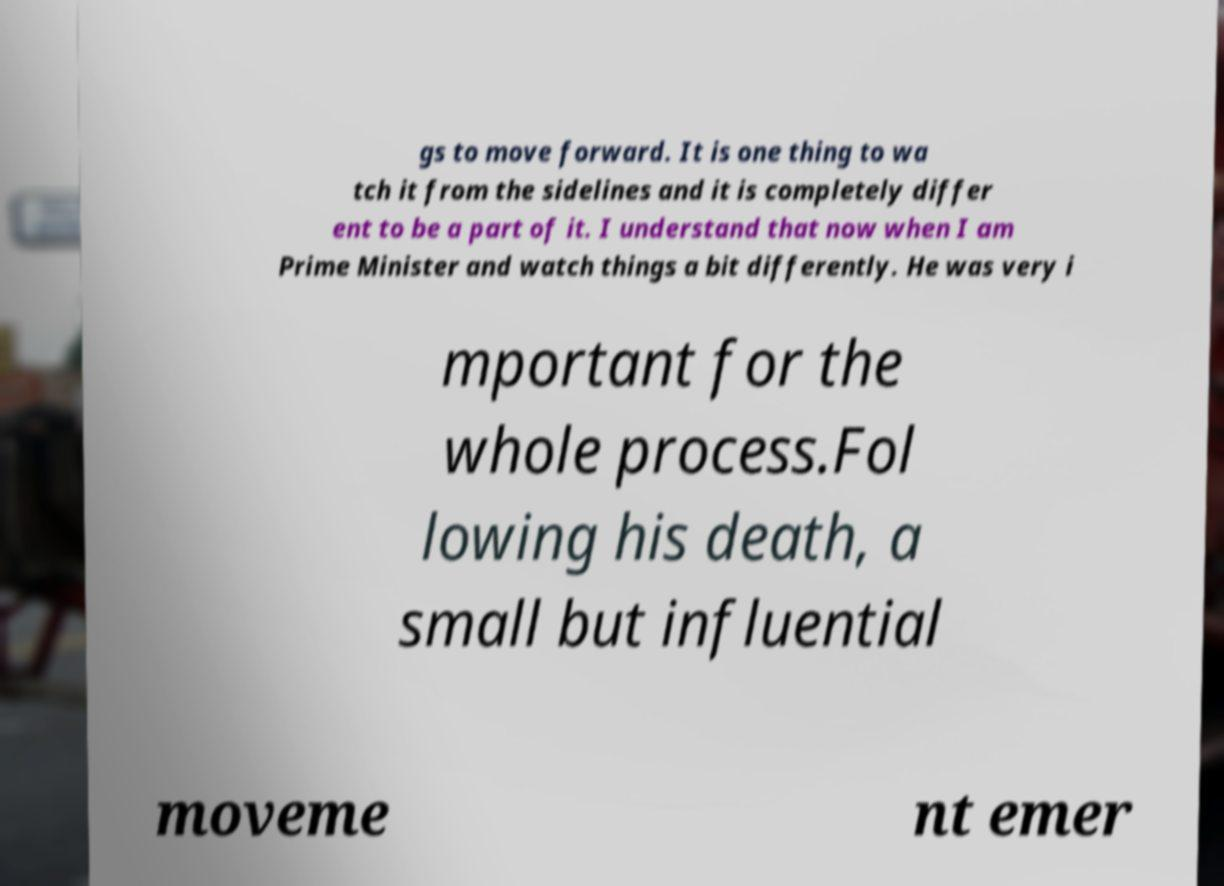Could you assist in decoding the text presented in this image and type it out clearly? gs to move forward. It is one thing to wa tch it from the sidelines and it is completely differ ent to be a part of it. I understand that now when I am Prime Minister and watch things a bit differently. He was very i mportant for the whole process.Fol lowing his death, a small but influential moveme nt emer 